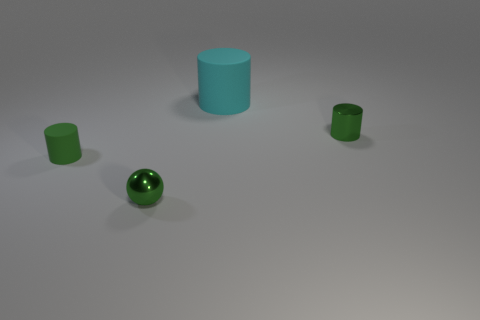Add 2 big matte things. How many objects exist? 6 Subtract all small shiny cylinders. How many cylinders are left? 2 Subtract all cyan cylinders. How many cylinders are left? 2 Subtract all red balls. How many cyan cylinders are left? 1 Subtract all small green cylinders. Subtract all big rubber cylinders. How many objects are left? 1 Add 1 green matte objects. How many green matte objects are left? 2 Add 4 green matte things. How many green matte things exist? 5 Subtract 1 green balls. How many objects are left? 3 Subtract all balls. How many objects are left? 3 Subtract 1 cylinders. How many cylinders are left? 2 